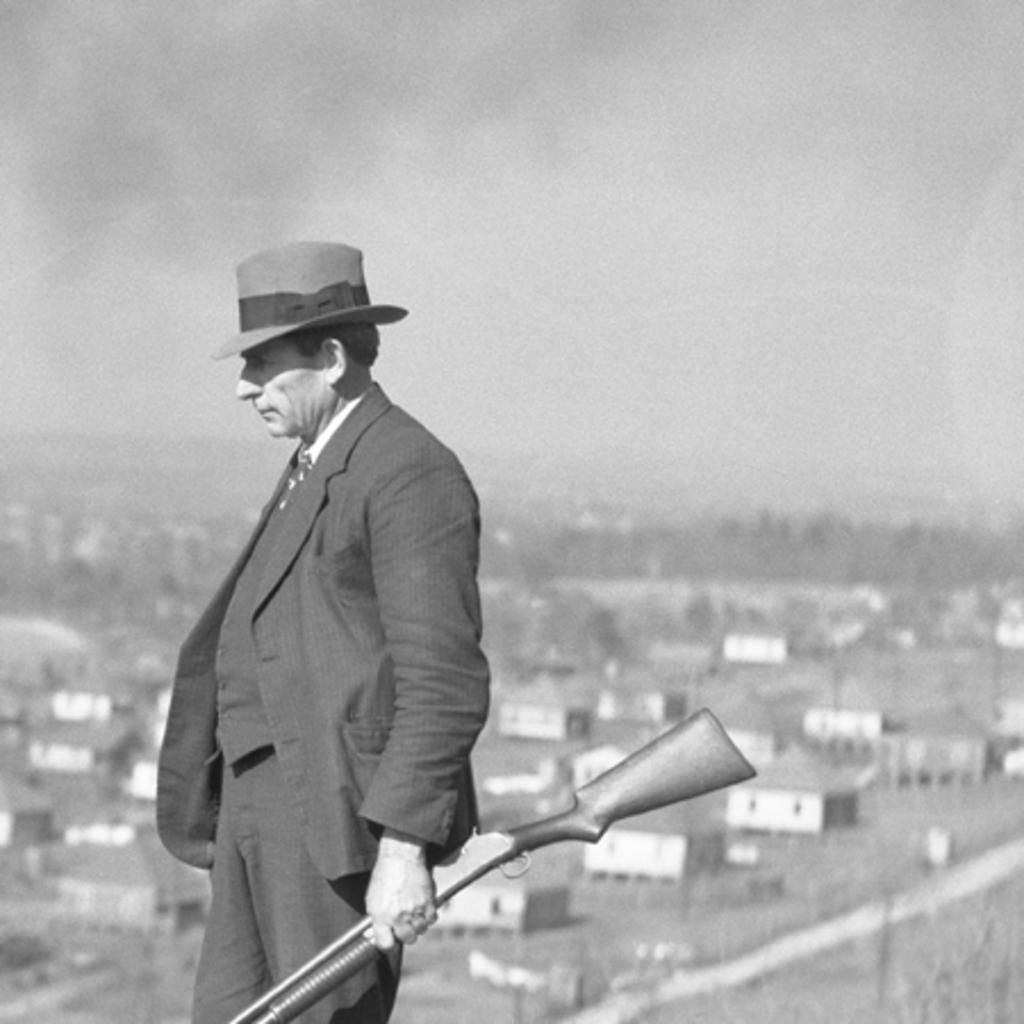Who is present in the image? There is a man in the image. What is the man holding in his hand? The man is holding a gun in his hand. What type of headwear is the man wearing? The man is wearing a cap on his head. What type of structures can be seen in the image? There are houses visible in the image. What part of the natural environment is visible in the image? The sky is visible in the image. Can you describe the man's haircut in the image? There is no information about the man's haircut in the image, as the focus is on the cap he is wearing. What type of harbor can be seen in the image? There is no harbor present in the image; it features a man holding a gun, wearing a cap, and standing in front of houses with a visible sky. 